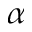<formula> <loc_0><loc_0><loc_500><loc_500>\alpha</formula> 